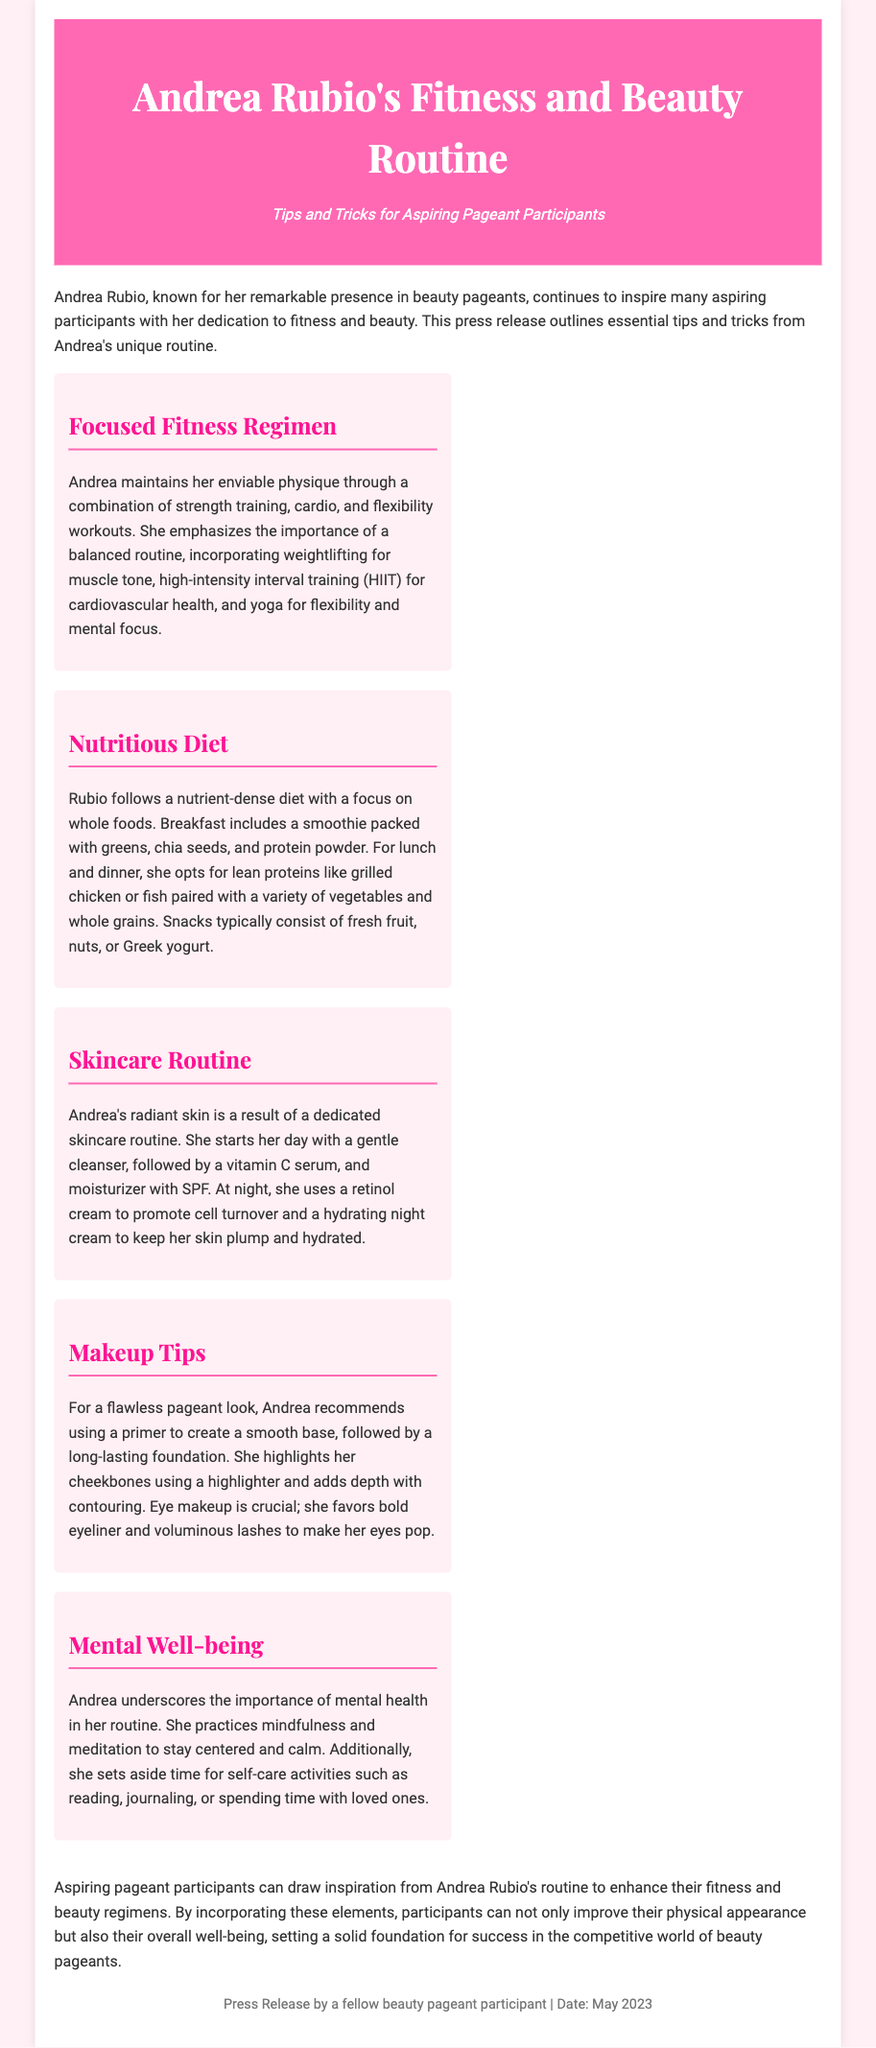What is Andrea Rubio known for? Andrea Rubio is known for her remarkable presence in beauty pageants.
Answer: beauty pageants What does Andrea emphasize in her fitness regimen? Andrea emphasizes a balanced routine that includes strength training, cardio, and flexibility workouts.
Answer: balanced routine What type of diet does Rubio follow? Rubio follows a nutrient-dense diet with a focus on whole foods.
Answer: whole foods What does Andrea use in her morning skincare routine? She uses a gentle cleanser, vitamin C serum, and moisturizer with SPF.
Answer: gentle cleanser What makeup product does Andrea recommend for a smooth base? Andrea recommends using a primer to create a smooth base.
Answer: primer What mental health practice does Andrea incorporate? Andrea practices mindfulness and meditation to stay centered and calm.
Answer: mindfulness and meditation What is the purpose of this press release? The purpose is to provide tips and tricks for aspiring pageant participants.
Answer: tips and tricks When was the press release dated? The press release was dated May 2023.
Answer: May 2023 